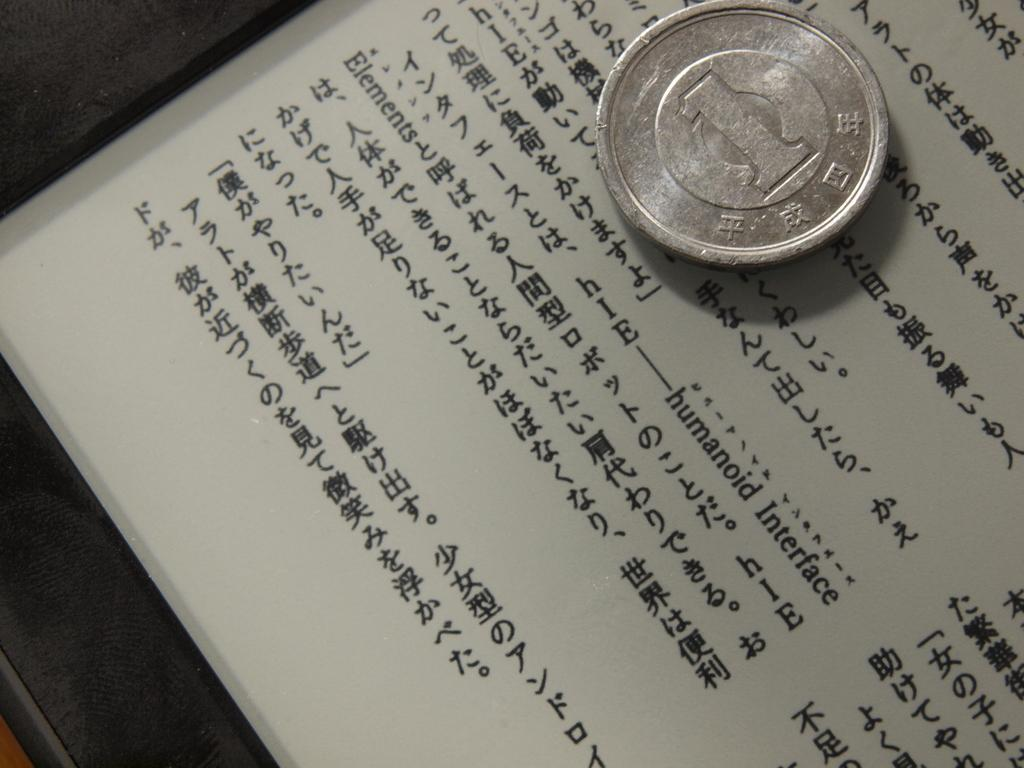<image>
Present a compact description of the photo's key features. A silver coin worth 1 on top of a paper with Asian writing, and the English word interface can be seen. 